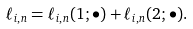Convert formula to latex. <formula><loc_0><loc_0><loc_500><loc_500>\ell _ { i , n } = \ell _ { i , n } ( 1 ; \bullet ) + \ell _ { i , n } ( 2 ; \bullet ) .</formula> 